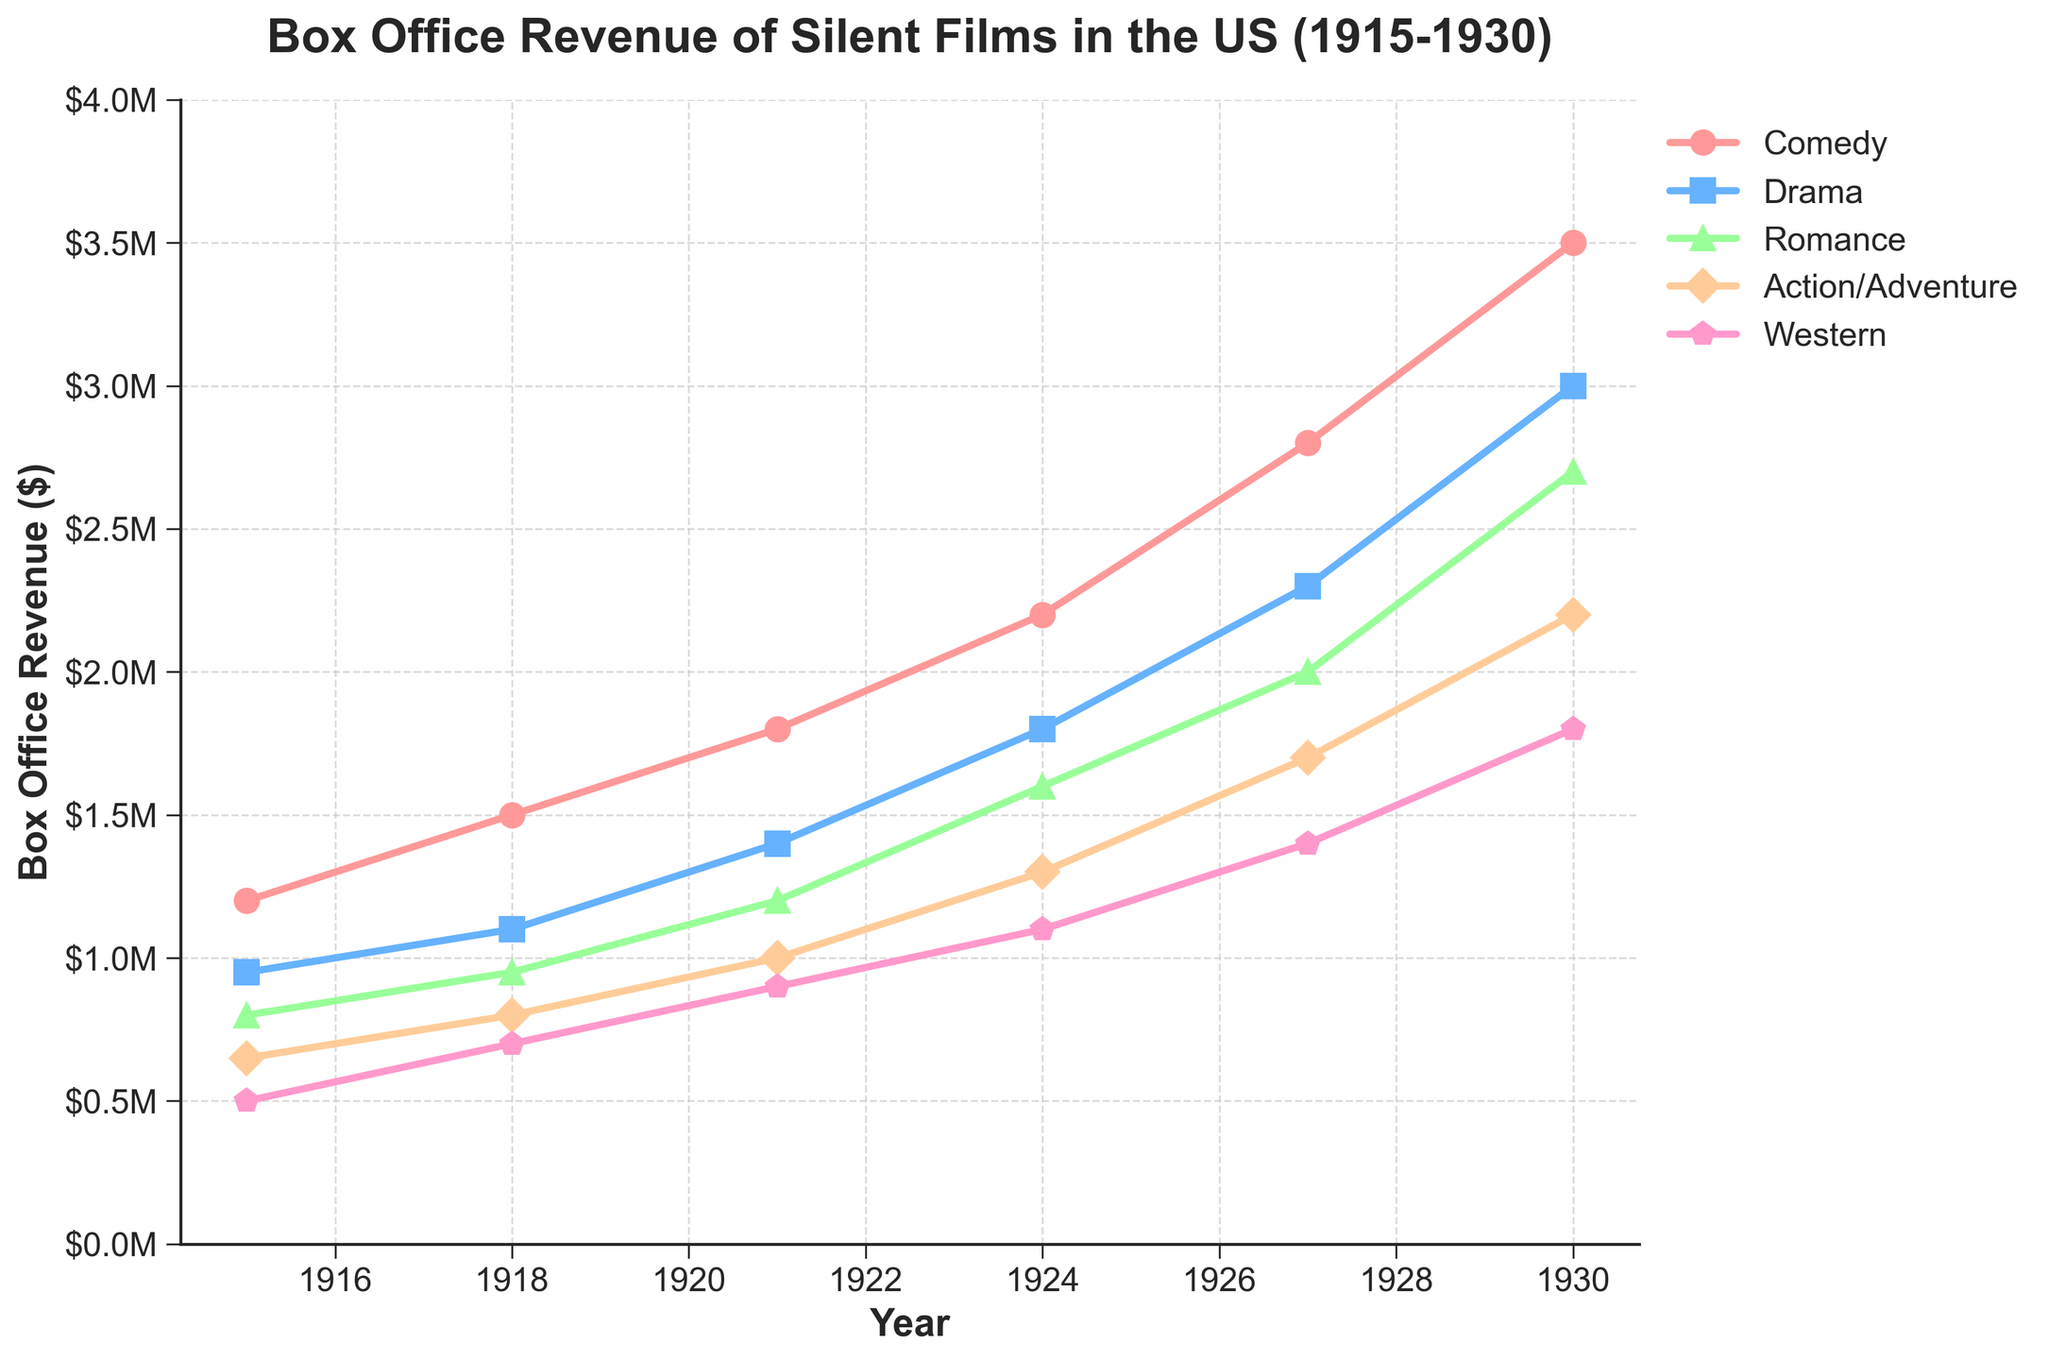What's the average box office revenue for the 'Drama' genre from 1915 to 1930? To find the average box office revenue for 'Drama', sum the values for 1915, 1918, 1921, 1924, 1927, and 1930, and divide by the number of years (6). The sum is 950000 + 1100000 + 1400000 + 1800000 + 2300000 + 3000000 = 10550000. The average is 10550000 / 6 = 1758333.33.
Answer: 1,758,333.33 Which genre had the highest box office revenue in 1930? To determine the highest genre in 1930, compare the values for Comedy, Drama, Romance, Action/Adventure, and Western. Comedy (3500000) had the highest revenue.
Answer: Comedy How much more in revenue did Comedy generate in 1930 compared to Western? Subtract the revenue of Western from Comedy in 1930. Comedy is 3500000 and Western is 1800000. So, 3500000 - 1800000 = 1700000.
Answer: 1,700,000 Which year saw the greatest revenue increase for Romance films compared to the previous year? Calculate the revenue increase between each consecutive pair of years for Romance and identify the largest increase: 1915 to 1918 (150000), 1918 to 1921 (250000), 1921 to 1924 (400000), 1924 to 1927 (400000), 1927 to 1930 (700000). The greatest increase is from 1927 to 1930.
Answer: 1927 to 1930 What is the total box office revenue for all genres combined in 1918? Sum the revenue for all genres in 1918: Comedy (1500000) + Drama (1100000) + Romance (950000) + Action/Adventure (800000) + Western (700000). The total is 5050000.
Answer: 5,050,000 Compare the box office revenue trend of Western to Action/Adventure from 1915 to 1930. Which genre had a steadier growth? Observe the line graphs of Western and Action/Adventure. Western revenue trends consistently upward from 500000 to 1800000, while Action/Adventure also trends upward but with some fluctuation from 650000 to 2200000. Western shows steadier growth.
Answer: Western Which genre experienced the smallest percentage increase in revenue from 1918 to 1921? Calculate the percentage increase for each genre from 1918 to 1921 and find the smallest:   Comedy (20%), Drama (27.27%), Romance (26.32%), Action/Adventure (25%), Western (28.57%). The smallest increase is in Comedy.
Answer: Comedy What can you infer about the popularity trend of the Comedy genre from 1915 to 1930? Observe the line for Comedy. Revenue increases consistently from 1200000 in 1915 to 3500000 in 1930, indicating rising popularity.
Answer: Increasing popularity 